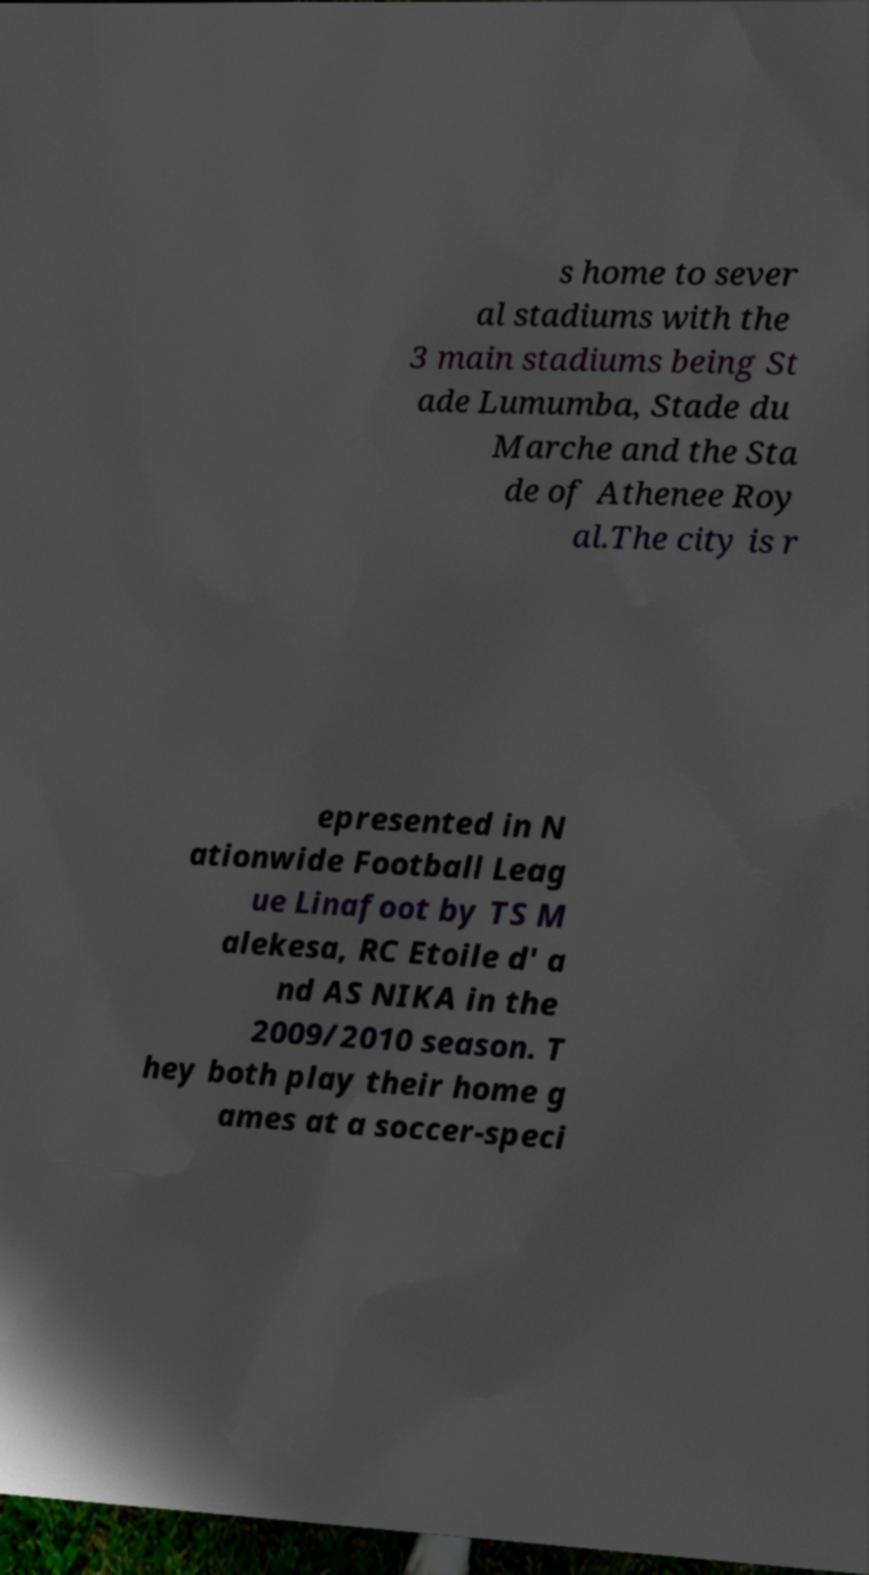There's text embedded in this image that I need extracted. Can you transcribe it verbatim? s home to sever al stadiums with the 3 main stadiums being St ade Lumumba, Stade du Marche and the Sta de of Athenee Roy al.The city is r epresented in N ationwide Football Leag ue Linafoot by TS M alekesa, RC Etoile d' a nd AS NIKA in the 2009/2010 season. T hey both play their home g ames at a soccer-speci 